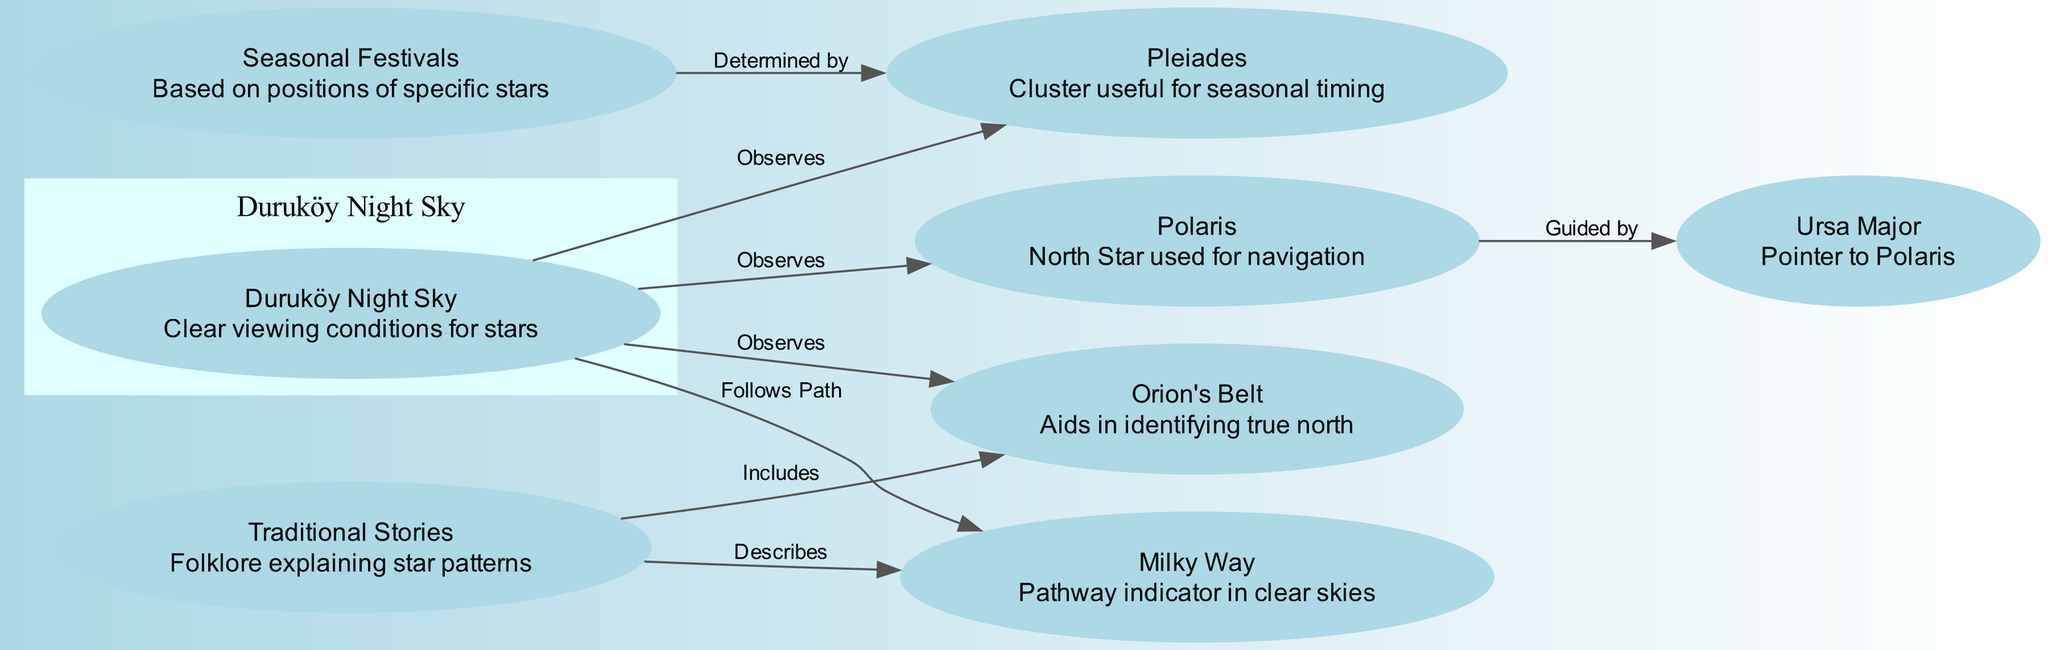What is the label of the node that indicates the North Star? The diagram shows that the node labeled as "Polaris" represents the North Star used for navigation. This identification comes from the description attached to the node.
Answer: Polaris How many nodes are present in the diagram? The diagram includes a total of 8 nodes, each representing different astronomical or cultural elements related to star navigation in Duruköy. This can be counted by listing each node in the data provided.
Answer: 8 What is the connection between Ursa Major and Polaris? The diagram specifies an edge labeled "Guided by" linking Ursa Major to Polaris, indicating that Ursa Major is used as a pointer to find Polaris in the night sky. This direct relationship is labeled on the edge connecting these two nodes.
Answer: Guided by Which cluster is useful for seasonal timing? The node labeled as "Pleiades" is indicated in the diagram as being useful for determining seasonal timings. This can be concluded from the description associated with this particular node.
Answer: Pleiades How does "Milky Way" relate to traditional stories? According to the diagram, "Milky Way" is described as being a pathway indicator that is included in traditional stories. This relationship is shown through the edge that connects the "Milky Way" node to the "Traditional Stories" node, labeled as "Describes".
Answer: Describes What does Duruköy Night Sky observe? The Duruköy Night Sky node observes multiple stars, including Polaris, Pleiades, Orion's Belt, and follows the pathway of the Milky Way. This relationship can be verified by looking at the edges linked to the "Duruköy Night Sky" node.
Answer: Polaris, Pleiades, Orion's Belt, Milky Way How do seasonal festivals relate to specific stars? The diagram states that seasonal festivals are determined by the positions of specific stars, and this is depicted through an edge that shows the connection from "Seasonal Festivals" to "Pleiades". This connection suggests that defining these festivals relies on the positions of stars like Pleiades.
Answer: Determined by What does "Orion's Belt" aid with? The node labeled as "Orion's Belt" assists in identifying true north, as explained in its description. This indicates its role in navigation and orientation for ancient travelers.
Answer: Identifying true north 